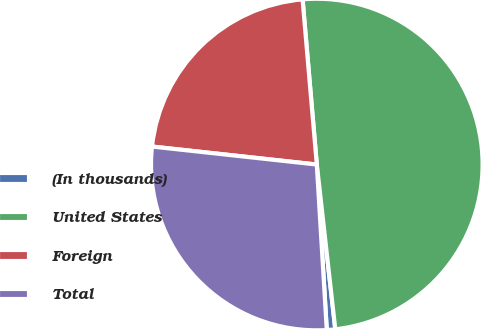<chart> <loc_0><loc_0><loc_500><loc_500><pie_chart><fcel>(In thousands)<fcel>United States<fcel>Foreign<fcel>Total<nl><fcel>0.82%<fcel>49.59%<fcel>21.9%<fcel>27.69%<nl></chart> 